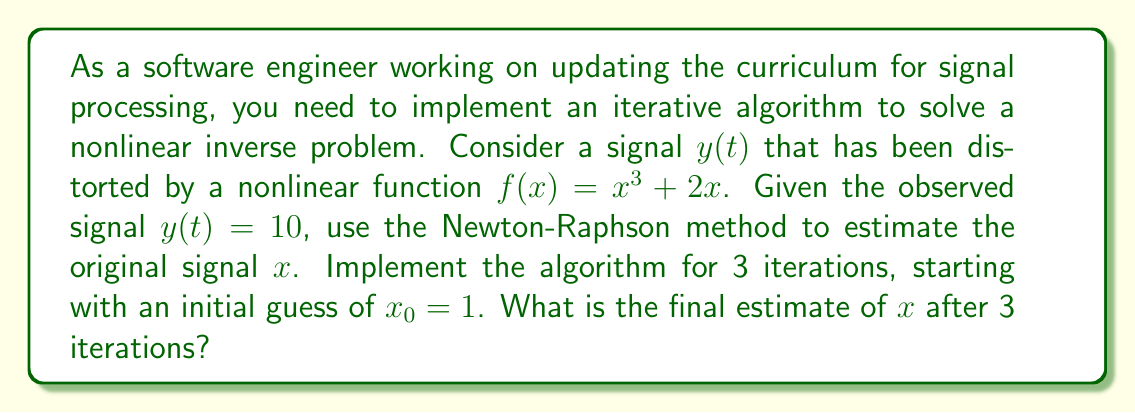Show me your answer to this math problem. To solve this nonlinear inverse problem using the Newton-Raphson method, we follow these steps:

1) The Newton-Raphson formula for this problem is:

   $$x_{n+1} = x_n - \frac{f(x_n) - y}{f'(x_n)}$$

   where $f(x) = x^3 + 2x$ and $y = 10$

2) We need to calculate $f'(x)$:
   
   $$f'(x) = 3x^2 + 2$$

3) Now, let's implement the iterations:

   Iteration 1:
   $$x_1 = 1 - \frac{(1^3 + 2(1)) - 10}{3(1)^2 + 2} = 1 - \frac{3 - 10}{5} = 1 + \frac{7}{5} = 2.4$$

   Iteration 2:
   $$x_2 = 2.4 - \frac{(2.4^3 + 2(2.4)) - 10}{3(2.4)^2 + 2} = 2.4 - \frac{19.104 - 10}{19.28} = 2.4 - 0.4721 = 1.9279$$

   Iteration 3:
   $$x_3 = 1.9279 - \frac{(1.9279^3 + 2(1.9279)) - 10}{3(1.9279)^2 + 2} = 1.9279 - \frac{11.1549 - 10}{13.1629} = 1.9279 - 0.0877 = 1.8402$$

4) Therefore, after 3 iterations, our final estimate of $x$ is approximately 1.8402.
Answer: 1.8402 